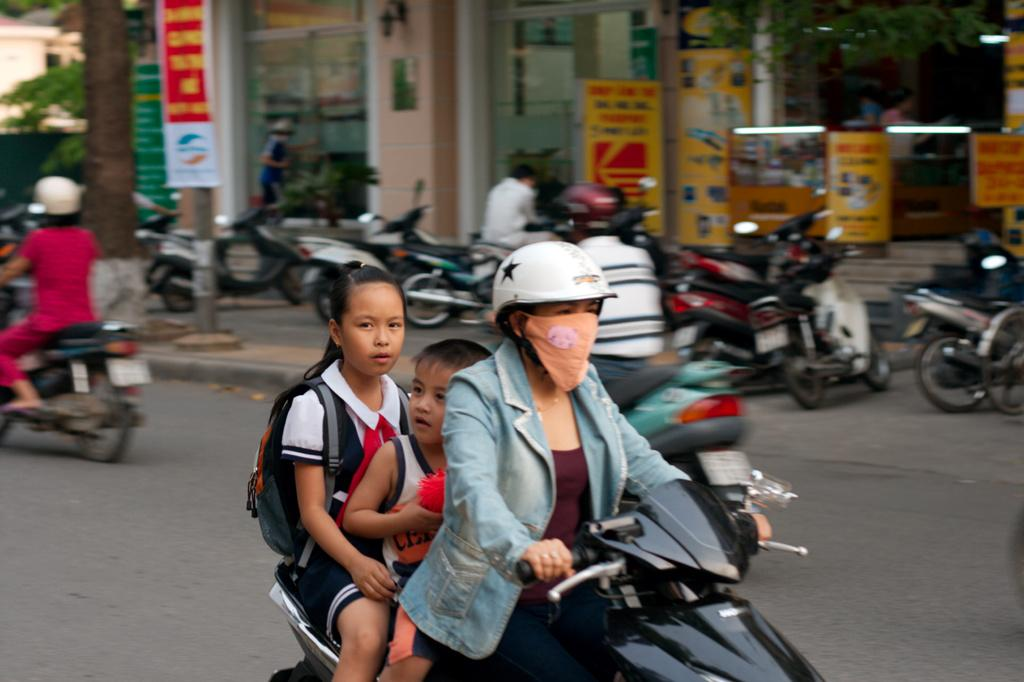What is the woman doing in the image? The woman is riding a scooter in the image. Who else is on the scooter with the woman? There are two kids sitting on the scooter. What can be seen in the background of the image? There are bikes and shops visible in the background of the image. What type of toothbrush is the woman using while riding the scooter? There is no toothbrush present in the image; the woman is riding a scooter with two kids on it. What songs are the kids singing while sitting on the scooter? There is no indication in the image that the kids are singing any songs; they are simply sitting on the scooter with the woman. 